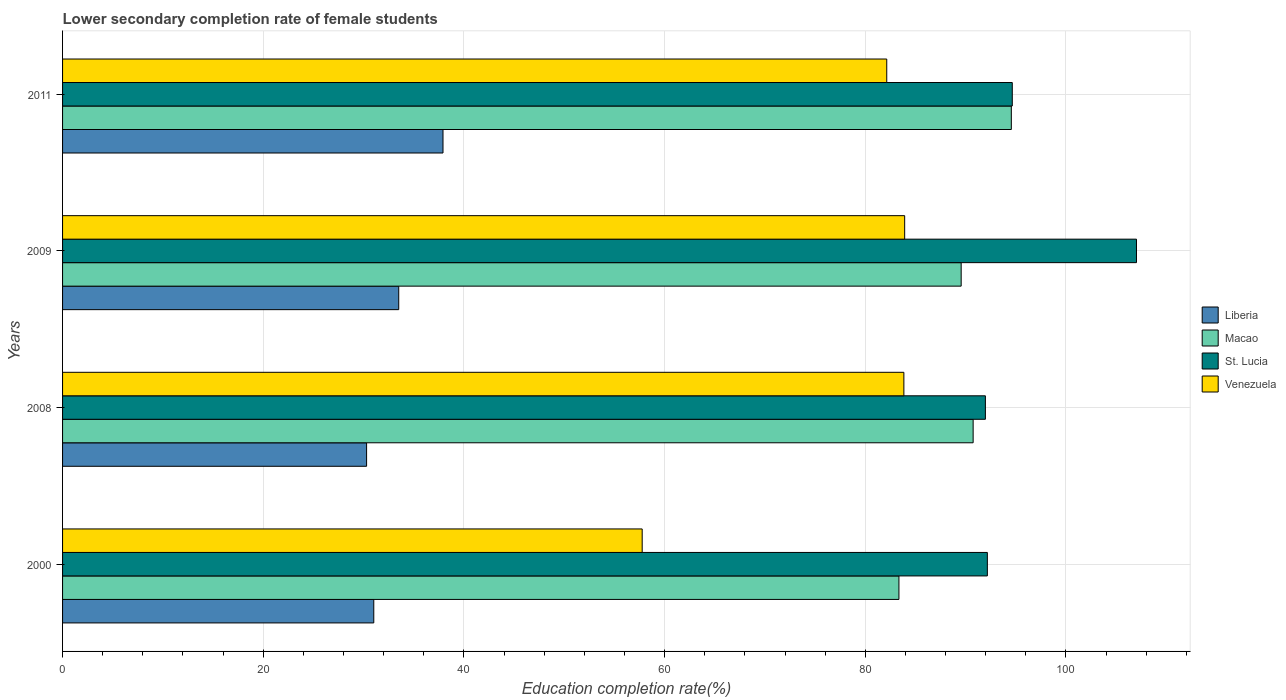How many different coloured bars are there?
Provide a short and direct response. 4. Are the number of bars on each tick of the Y-axis equal?
Offer a terse response. Yes. What is the lower secondary completion rate of female students in Macao in 2008?
Make the answer very short. 90.75. Across all years, what is the maximum lower secondary completion rate of female students in Liberia?
Offer a terse response. 37.91. Across all years, what is the minimum lower secondary completion rate of female students in Venezuela?
Give a very brief answer. 57.76. In which year was the lower secondary completion rate of female students in Venezuela maximum?
Make the answer very short. 2009. In which year was the lower secondary completion rate of female students in St. Lucia minimum?
Offer a terse response. 2008. What is the total lower secondary completion rate of female students in Liberia in the graph?
Provide a short and direct response. 132.73. What is the difference between the lower secondary completion rate of female students in Venezuela in 2008 and that in 2011?
Ensure brevity in your answer.  1.71. What is the difference between the lower secondary completion rate of female students in St. Lucia in 2009 and the lower secondary completion rate of female students in Macao in 2008?
Your response must be concise. 16.28. What is the average lower secondary completion rate of female students in Liberia per year?
Offer a very short reply. 33.18. In the year 2011, what is the difference between the lower secondary completion rate of female students in Venezuela and lower secondary completion rate of female students in Macao?
Ensure brevity in your answer.  -12.41. In how many years, is the lower secondary completion rate of female students in St. Lucia greater than 108 %?
Provide a succinct answer. 0. What is the ratio of the lower secondary completion rate of female students in Venezuela in 2008 to that in 2011?
Make the answer very short. 1.02. Is the difference between the lower secondary completion rate of female students in Venezuela in 2008 and 2009 greater than the difference between the lower secondary completion rate of female students in Macao in 2008 and 2009?
Ensure brevity in your answer.  No. What is the difference between the highest and the second highest lower secondary completion rate of female students in Venezuela?
Your answer should be very brief. 0.08. What is the difference between the highest and the lowest lower secondary completion rate of female students in Liberia?
Your answer should be compact. 7.61. Is the sum of the lower secondary completion rate of female students in Macao in 2000 and 2008 greater than the maximum lower secondary completion rate of female students in St. Lucia across all years?
Ensure brevity in your answer.  Yes. What does the 1st bar from the top in 2009 represents?
Your answer should be very brief. Venezuela. What does the 2nd bar from the bottom in 2000 represents?
Make the answer very short. Macao. Is it the case that in every year, the sum of the lower secondary completion rate of female students in Macao and lower secondary completion rate of female students in Venezuela is greater than the lower secondary completion rate of female students in St. Lucia?
Keep it short and to the point. Yes. How many bars are there?
Keep it short and to the point. 16. Are all the bars in the graph horizontal?
Ensure brevity in your answer.  Yes. How many years are there in the graph?
Your answer should be very brief. 4. Are the values on the major ticks of X-axis written in scientific E-notation?
Give a very brief answer. No. Does the graph contain grids?
Keep it short and to the point. Yes. What is the title of the graph?
Ensure brevity in your answer.  Lower secondary completion rate of female students. Does "Cabo Verde" appear as one of the legend labels in the graph?
Offer a terse response. No. What is the label or title of the X-axis?
Ensure brevity in your answer.  Education completion rate(%). What is the label or title of the Y-axis?
Offer a terse response. Years. What is the Education completion rate(%) of Liberia in 2000?
Your answer should be compact. 31.02. What is the Education completion rate(%) of Macao in 2000?
Offer a very short reply. 83.35. What is the Education completion rate(%) in St. Lucia in 2000?
Your response must be concise. 92.16. What is the Education completion rate(%) of Venezuela in 2000?
Make the answer very short. 57.76. What is the Education completion rate(%) in Liberia in 2008?
Provide a short and direct response. 30.3. What is the Education completion rate(%) of Macao in 2008?
Your answer should be compact. 90.75. What is the Education completion rate(%) in St. Lucia in 2008?
Give a very brief answer. 91.97. What is the Education completion rate(%) of Venezuela in 2008?
Ensure brevity in your answer.  83.84. What is the Education completion rate(%) of Liberia in 2009?
Provide a short and direct response. 33.5. What is the Education completion rate(%) in Macao in 2009?
Your response must be concise. 89.55. What is the Education completion rate(%) of St. Lucia in 2009?
Your response must be concise. 107.03. What is the Education completion rate(%) in Venezuela in 2009?
Give a very brief answer. 83.92. What is the Education completion rate(%) in Liberia in 2011?
Your response must be concise. 37.91. What is the Education completion rate(%) in Macao in 2011?
Offer a very short reply. 94.55. What is the Education completion rate(%) of St. Lucia in 2011?
Your answer should be very brief. 94.65. What is the Education completion rate(%) of Venezuela in 2011?
Your answer should be compact. 82.14. Across all years, what is the maximum Education completion rate(%) in Liberia?
Provide a succinct answer. 37.91. Across all years, what is the maximum Education completion rate(%) in Macao?
Offer a very short reply. 94.55. Across all years, what is the maximum Education completion rate(%) of St. Lucia?
Make the answer very short. 107.03. Across all years, what is the maximum Education completion rate(%) of Venezuela?
Make the answer very short. 83.92. Across all years, what is the minimum Education completion rate(%) of Liberia?
Your response must be concise. 30.3. Across all years, what is the minimum Education completion rate(%) in Macao?
Your response must be concise. 83.35. Across all years, what is the minimum Education completion rate(%) of St. Lucia?
Your response must be concise. 91.97. Across all years, what is the minimum Education completion rate(%) in Venezuela?
Keep it short and to the point. 57.76. What is the total Education completion rate(%) of Liberia in the graph?
Make the answer very short. 132.73. What is the total Education completion rate(%) in Macao in the graph?
Your answer should be very brief. 358.21. What is the total Education completion rate(%) in St. Lucia in the graph?
Make the answer very short. 385.81. What is the total Education completion rate(%) in Venezuela in the graph?
Ensure brevity in your answer.  307.67. What is the difference between the Education completion rate(%) of Liberia in 2000 and that in 2008?
Your response must be concise. 0.72. What is the difference between the Education completion rate(%) of Macao in 2000 and that in 2008?
Provide a succinct answer. -7.4. What is the difference between the Education completion rate(%) of St. Lucia in 2000 and that in 2008?
Your answer should be compact. 0.2. What is the difference between the Education completion rate(%) in Venezuela in 2000 and that in 2008?
Make the answer very short. -26.08. What is the difference between the Education completion rate(%) of Liberia in 2000 and that in 2009?
Make the answer very short. -2.49. What is the difference between the Education completion rate(%) in Macao in 2000 and that in 2009?
Ensure brevity in your answer.  -6.2. What is the difference between the Education completion rate(%) in St. Lucia in 2000 and that in 2009?
Provide a succinct answer. -14.86. What is the difference between the Education completion rate(%) in Venezuela in 2000 and that in 2009?
Offer a terse response. -26.16. What is the difference between the Education completion rate(%) in Liberia in 2000 and that in 2011?
Offer a very short reply. -6.9. What is the difference between the Education completion rate(%) in Macao in 2000 and that in 2011?
Provide a succinct answer. -11.2. What is the difference between the Education completion rate(%) of St. Lucia in 2000 and that in 2011?
Provide a short and direct response. -2.48. What is the difference between the Education completion rate(%) in Venezuela in 2000 and that in 2011?
Make the answer very short. -24.37. What is the difference between the Education completion rate(%) in Liberia in 2008 and that in 2009?
Provide a succinct answer. -3.2. What is the difference between the Education completion rate(%) in Macao in 2008 and that in 2009?
Your response must be concise. 1.19. What is the difference between the Education completion rate(%) of St. Lucia in 2008 and that in 2009?
Provide a succinct answer. -15.06. What is the difference between the Education completion rate(%) of Venezuela in 2008 and that in 2009?
Your answer should be very brief. -0.08. What is the difference between the Education completion rate(%) of Liberia in 2008 and that in 2011?
Provide a succinct answer. -7.61. What is the difference between the Education completion rate(%) of Macao in 2008 and that in 2011?
Give a very brief answer. -3.8. What is the difference between the Education completion rate(%) in St. Lucia in 2008 and that in 2011?
Your answer should be compact. -2.68. What is the difference between the Education completion rate(%) of Venezuela in 2008 and that in 2011?
Give a very brief answer. 1.71. What is the difference between the Education completion rate(%) of Liberia in 2009 and that in 2011?
Make the answer very short. -4.41. What is the difference between the Education completion rate(%) in Macao in 2009 and that in 2011?
Provide a short and direct response. -5. What is the difference between the Education completion rate(%) in St. Lucia in 2009 and that in 2011?
Give a very brief answer. 12.38. What is the difference between the Education completion rate(%) in Venezuela in 2009 and that in 2011?
Ensure brevity in your answer.  1.79. What is the difference between the Education completion rate(%) of Liberia in 2000 and the Education completion rate(%) of Macao in 2008?
Offer a terse response. -59.73. What is the difference between the Education completion rate(%) in Liberia in 2000 and the Education completion rate(%) in St. Lucia in 2008?
Offer a very short reply. -60.95. What is the difference between the Education completion rate(%) of Liberia in 2000 and the Education completion rate(%) of Venezuela in 2008?
Offer a very short reply. -52.83. What is the difference between the Education completion rate(%) of Macao in 2000 and the Education completion rate(%) of St. Lucia in 2008?
Offer a terse response. -8.62. What is the difference between the Education completion rate(%) in Macao in 2000 and the Education completion rate(%) in Venezuela in 2008?
Give a very brief answer. -0.49. What is the difference between the Education completion rate(%) of St. Lucia in 2000 and the Education completion rate(%) of Venezuela in 2008?
Keep it short and to the point. 8.32. What is the difference between the Education completion rate(%) in Liberia in 2000 and the Education completion rate(%) in Macao in 2009?
Keep it short and to the point. -58.54. What is the difference between the Education completion rate(%) in Liberia in 2000 and the Education completion rate(%) in St. Lucia in 2009?
Your answer should be very brief. -76.01. What is the difference between the Education completion rate(%) in Liberia in 2000 and the Education completion rate(%) in Venezuela in 2009?
Provide a succinct answer. -52.91. What is the difference between the Education completion rate(%) in Macao in 2000 and the Education completion rate(%) in St. Lucia in 2009?
Your response must be concise. -23.67. What is the difference between the Education completion rate(%) of Macao in 2000 and the Education completion rate(%) of Venezuela in 2009?
Your response must be concise. -0.57. What is the difference between the Education completion rate(%) of St. Lucia in 2000 and the Education completion rate(%) of Venezuela in 2009?
Ensure brevity in your answer.  8.24. What is the difference between the Education completion rate(%) in Liberia in 2000 and the Education completion rate(%) in Macao in 2011?
Your answer should be very brief. -63.54. What is the difference between the Education completion rate(%) in Liberia in 2000 and the Education completion rate(%) in St. Lucia in 2011?
Provide a short and direct response. -63.63. What is the difference between the Education completion rate(%) in Liberia in 2000 and the Education completion rate(%) in Venezuela in 2011?
Offer a terse response. -51.12. What is the difference between the Education completion rate(%) of Macao in 2000 and the Education completion rate(%) of St. Lucia in 2011?
Your response must be concise. -11.3. What is the difference between the Education completion rate(%) in Macao in 2000 and the Education completion rate(%) in Venezuela in 2011?
Your response must be concise. 1.21. What is the difference between the Education completion rate(%) of St. Lucia in 2000 and the Education completion rate(%) of Venezuela in 2011?
Keep it short and to the point. 10.03. What is the difference between the Education completion rate(%) of Liberia in 2008 and the Education completion rate(%) of Macao in 2009?
Make the answer very short. -59.25. What is the difference between the Education completion rate(%) in Liberia in 2008 and the Education completion rate(%) in St. Lucia in 2009?
Your answer should be very brief. -76.73. What is the difference between the Education completion rate(%) of Liberia in 2008 and the Education completion rate(%) of Venezuela in 2009?
Provide a succinct answer. -53.62. What is the difference between the Education completion rate(%) of Macao in 2008 and the Education completion rate(%) of St. Lucia in 2009?
Give a very brief answer. -16.28. What is the difference between the Education completion rate(%) in Macao in 2008 and the Education completion rate(%) in Venezuela in 2009?
Keep it short and to the point. 6.82. What is the difference between the Education completion rate(%) of St. Lucia in 2008 and the Education completion rate(%) of Venezuela in 2009?
Your response must be concise. 8.04. What is the difference between the Education completion rate(%) in Liberia in 2008 and the Education completion rate(%) in Macao in 2011?
Offer a terse response. -64.25. What is the difference between the Education completion rate(%) in Liberia in 2008 and the Education completion rate(%) in St. Lucia in 2011?
Your answer should be very brief. -64.35. What is the difference between the Education completion rate(%) in Liberia in 2008 and the Education completion rate(%) in Venezuela in 2011?
Give a very brief answer. -51.84. What is the difference between the Education completion rate(%) of Macao in 2008 and the Education completion rate(%) of St. Lucia in 2011?
Your answer should be compact. -3.9. What is the difference between the Education completion rate(%) of Macao in 2008 and the Education completion rate(%) of Venezuela in 2011?
Your answer should be compact. 8.61. What is the difference between the Education completion rate(%) in St. Lucia in 2008 and the Education completion rate(%) in Venezuela in 2011?
Make the answer very short. 9.83. What is the difference between the Education completion rate(%) in Liberia in 2009 and the Education completion rate(%) in Macao in 2011?
Ensure brevity in your answer.  -61.05. What is the difference between the Education completion rate(%) of Liberia in 2009 and the Education completion rate(%) of St. Lucia in 2011?
Give a very brief answer. -61.15. What is the difference between the Education completion rate(%) of Liberia in 2009 and the Education completion rate(%) of Venezuela in 2011?
Provide a succinct answer. -48.64. What is the difference between the Education completion rate(%) in Macao in 2009 and the Education completion rate(%) in St. Lucia in 2011?
Keep it short and to the point. -5.09. What is the difference between the Education completion rate(%) of Macao in 2009 and the Education completion rate(%) of Venezuela in 2011?
Provide a short and direct response. 7.42. What is the difference between the Education completion rate(%) of St. Lucia in 2009 and the Education completion rate(%) of Venezuela in 2011?
Ensure brevity in your answer.  24.89. What is the average Education completion rate(%) of Liberia per year?
Offer a terse response. 33.18. What is the average Education completion rate(%) in Macao per year?
Your answer should be compact. 89.55. What is the average Education completion rate(%) in St. Lucia per year?
Your answer should be compact. 96.45. What is the average Education completion rate(%) of Venezuela per year?
Give a very brief answer. 76.92. In the year 2000, what is the difference between the Education completion rate(%) in Liberia and Education completion rate(%) in Macao?
Provide a succinct answer. -52.34. In the year 2000, what is the difference between the Education completion rate(%) of Liberia and Education completion rate(%) of St. Lucia?
Keep it short and to the point. -61.15. In the year 2000, what is the difference between the Education completion rate(%) of Liberia and Education completion rate(%) of Venezuela?
Your answer should be very brief. -26.75. In the year 2000, what is the difference between the Education completion rate(%) of Macao and Education completion rate(%) of St. Lucia?
Keep it short and to the point. -8.81. In the year 2000, what is the difference between the Education completion rate(%) in Macao and Education completion rate(%) in Venezuela?
Ensure brevity in your answer.  25.59. In the year 2000, what is the difference between the Education completion rate(%) in St. Lucia and Education completion rate(%) in Venezuela?
Provide a short and direct response. 34.4. In the year 2008, what is the difference between the Education completion rate(%) of Liberia and Education completion rate(%) of Macao?
Ensure brevity in your answer.  -60.45. In the year 2008, what is the difference between the Education completion rate(%) in Liberia and Education completion rate(%) in St. Lucia?
Provide a short and direct response. -61.67. In the year 2008, what is the difference between the Education completion rate(%) of Liberia and Education completion rate(%) of Venezuela?
Your response must be concise. -53.54. In the year 2008, what is the difference between the Education completion rate(%) in Macao and Education completion rate(%) in St. Lucia?
Make the answer very short. -1.22. In the year 2008, what is the difference between the Education completion rate(%) of Macao and Education completion rate(%) of Venezuela?
Your answer should be very brief. 6.9. In the year 2008, what is the difference between the Education completion rate(%) of St. Lucia and Education completion rate(%) of Venezuela?
Offer a terse response. 8.12. In the year 2009, what is the difference between the Education completion rate(%) in Liberia and Education completion rate(%) in Macao?
Provide a short and direct response. -56.05. In the year 2009, what is the difference between the Education completion rate(%) of Liberia and Education completion rate(%) of St. Lucia?
Provide a short and direct response. -73.52. In the year 2009, what is the difference between the Education completion rate(%) in Liberia and Education completion rate(%) in Venezuela?
Offer a terse response. -50.42. In the year 2009, what is the difference between the Education completion rate(%) in Macao and Education completion rate(%) in St. Lucia?
Keep it short and to the point. -17.47. In the year 2009, what is the difference between the Education completion rate(%) in Macao and Education completion rate(%) in Venezuela?
Offer a terse response. 5.63. In the year 2009, what is the difference between the Education completion rate(%) in St. Lucia and Education completion rate(%) in Venezuela?
Your response must be concise. 23.1. In the year 2011, what is the difference between the Education completion rate(%) of Liberia and Education completion rate(%) of Macao?
Provide a short and direct response. -56.64. In the year 2011, what is the difference between the Education completion rate(%) of Liberia and Education completion rate(%) of St. Lucia?
Make the answer very short. -56.73. In the year 2011, what is the difference between the Education completion rate(%) of Liberia and Education completion rate(%) of Venezuela?
Ensure brevity in your answer.  -44.22. In the year 2011, what is the difference between the Education completion rate(%) of Macao and Education completion rate(%) of St. Lucia?
Provide a short and direct response. -0.1. In the year 2011, what is the difference between the Education completion rate(%) in Macao and Education completion rate(%) in Venezuela?
Keep it short and to the point. 12.41. In the year 2011, what is the difference between the Education completion rate(%) of St. Lucia and Education completion rate(%) of Venezuela?
Your answer should be very brief. 12.51. What is the ratio of the Education completion rate(%) in Liberia in 2000 to that in 2008?
Keep it short and to the point. 1.02. What is the ratio of the Education completion rate(%) in Macao in 2000 to that in 2008?
Provide a short and direct response. 0.92. What is the ratio of the Education completion rate(%) in St. Lucia in 2000 to that in 2008?
Your answer should be very brief. 1. What is the ratio of the Education completion rate(%) in Venezuela in 2000 to that in 2008?
Your answer should be very brief. 0.69. What is the ratio of the Education completion rate(%) of Liberia in 2000 to that in 2009?
Your answer should be very brief. 0.93. What is the ratio of the Education completion rate(%) in Macao in 2000 to that in 2009?
Provide a succinct answer. 0.93. What is the ratio of the Education completion rate(%) in St. Lucia in 2000 to that in 2009?
Your answer should be very brief. 0.86. What is the ratio of the Education completion rate(%) of Venezuela in 2000 to that in 2009?
Ensure brevity in your answer.  0.69. What is the ratio of the Education completion rate(%) of Liberia in 2000 to that in 2011?
Keep it short and to the point. 0.82. What is the ratio of the Education completion rate(%) in Macao in 2000 to that in 2011?
Offer a very short reply. 0.88. What is the ratio of the Education completion rate(%) in St. Lucia in 2000 to that in 2011?
Your answer should be compact. 0.97. What is the ratio of the Education completion rate(%) of Venezuela in 2000 to that in 2011?
Keep it short and to the point. 0.7. What is the ratio of the Education completion rate(%) of Liberia in 2008 to that in 2009?
Offer a terse response. 0.9. What is the ratio of the Education completion rate(%) of Macao in 2008 to that in 2009?
Provide a short and direct response. 1.01. What is the ratio of the Education completion rate(%) of St. Lucia in 2008 to that in 2009?
Offer a very short reply. 0.86. What is the ratio of the Education completion rate(%) in Venezuela in 2008 to that in 2009?
Make the answer very short. 1. What is the ratio of the Education completion rate(%) of Liberia in 2008 to that in 2011?
Provide a succinct answer. 0.8. What is the ratio of the Education completion rate(%) in Macao in 2008 to that in 2011?
Offer a terse response. 0.96. What is the ratio of the Education completion rate(%) of St. Lucia in 2008 to that in 2011?
Your answer should be very brief. 0.97. What is the ratio of the Education completion rate(%) of Venezuela in 2008 to that in 2011?
Your response must be concise. 1.02. What is the ratio of the Education completion rate(%) in Liberia in 2009 to that in 2011?
Keep it short and to the point. 0.88. What is the ratio of the Education completion rate(%) of Macao in 2009 to that in 2011?
Provide a succinct answer. 0.95. What is the ratio of the Education completion rate(%) in St. Lucia in 2009 to that in 2011?
Provide a short and direct response. 1.13. What is the ratio of the Education completion rate(%) of Venezuela in 2009 to that in 2011?
Keep it short and to the point. 1.02. What is the difference between the highest and the second highest Education completion rate(%) of Liberia?
Your answer should be compact. 4.41. What is the difference between the highest and the second highest Education completion rate(%) in Macao?
Provide a short and direct response. 3.8. What is the difference between the highest and the second highest Education completion rate(%) in St. Lucia?
Your answer should be very brief. 12.38. What is the difference between the highest and the second highest Education completion rate(%) of Venezuela?
Offer a very short reply. 0.08. What is the difference between the highest and the lowest Education completion rate(%) in Liberia?
Your response must be concise. 7.61. What is the difference between the highest and the lowest Education completion rate(%) of Macao?
Your answer should be compact. 11.2. What is the difference between the highest and the lowest Education completion rate(%) in St. Lucia?
Your answer should be compact. 15.06. What is the difference between the highest and the lowest Education completion rate(%) in Venezuela?
Give a very brief answer. 26.16. 